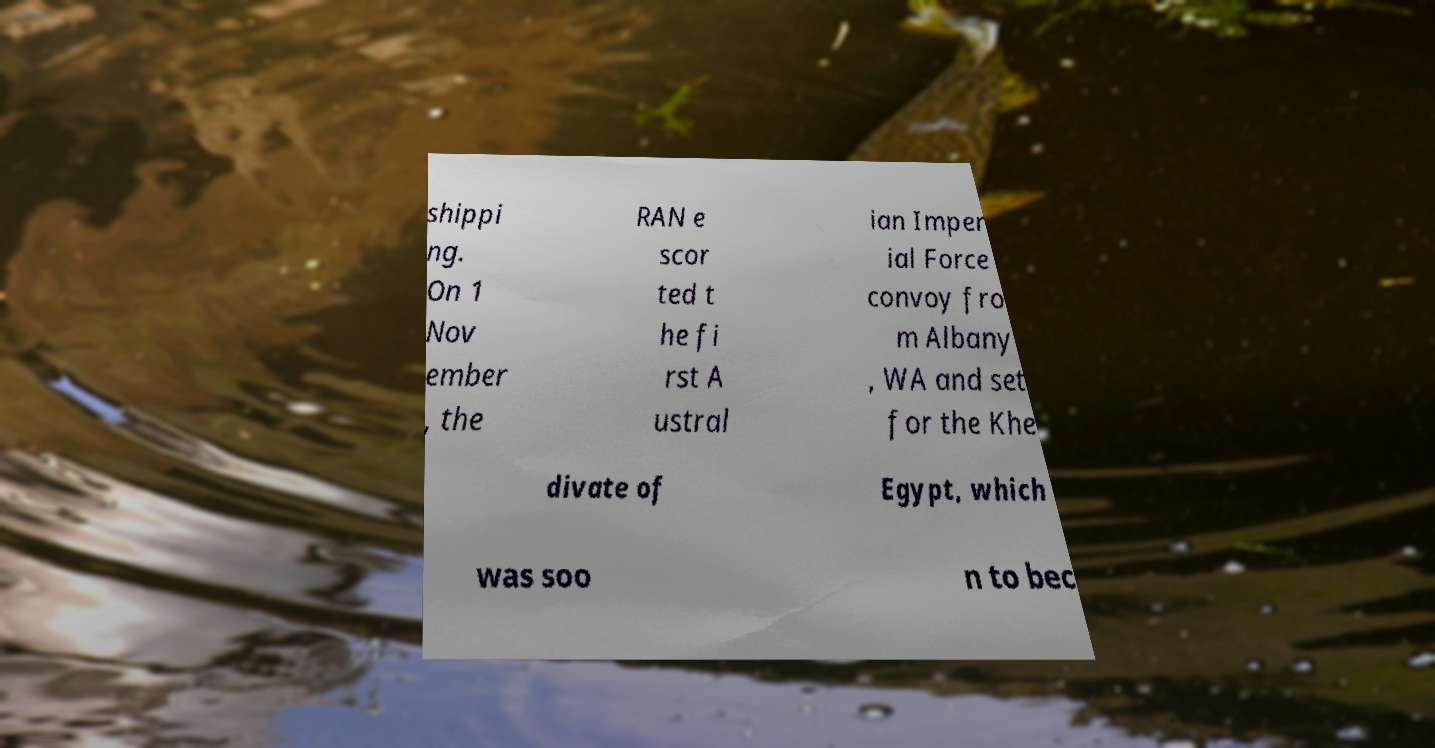Can you accurately transcribe the text from the provided image for me? shippi ng. On 1 Nov ember , the RAN e scor ted t he fi rst A ustral ian Imper ial Force convoy fro m Albany , WA and set for the Khe divate of Egypt, which was soo n to bec 